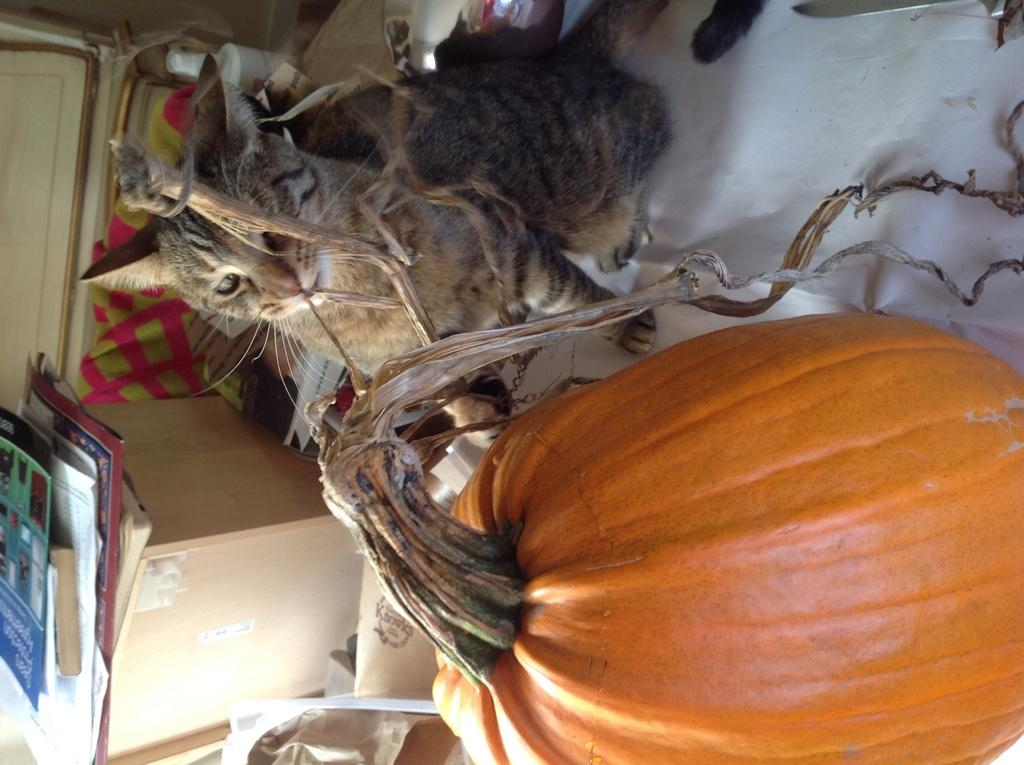What type of animal is in the image? There is a cat in the image. What season might the image be associated with, considering the presence of a pumpkin? The image might be associated with fall, as pumpkins are often used during that season. What object in the image can be used for storage? There is a box in the image that can be used for storage. What material is present in the image? There is cloth in the image. What items in the image might be used for learning or entertainment? There are books in the image that might be used for learning or entertainment. What type of metal can be seen in the image? There is no metal present in the image. What direction is the cat pointing in the image? The image does not show the cat pointing in any specific direction. 